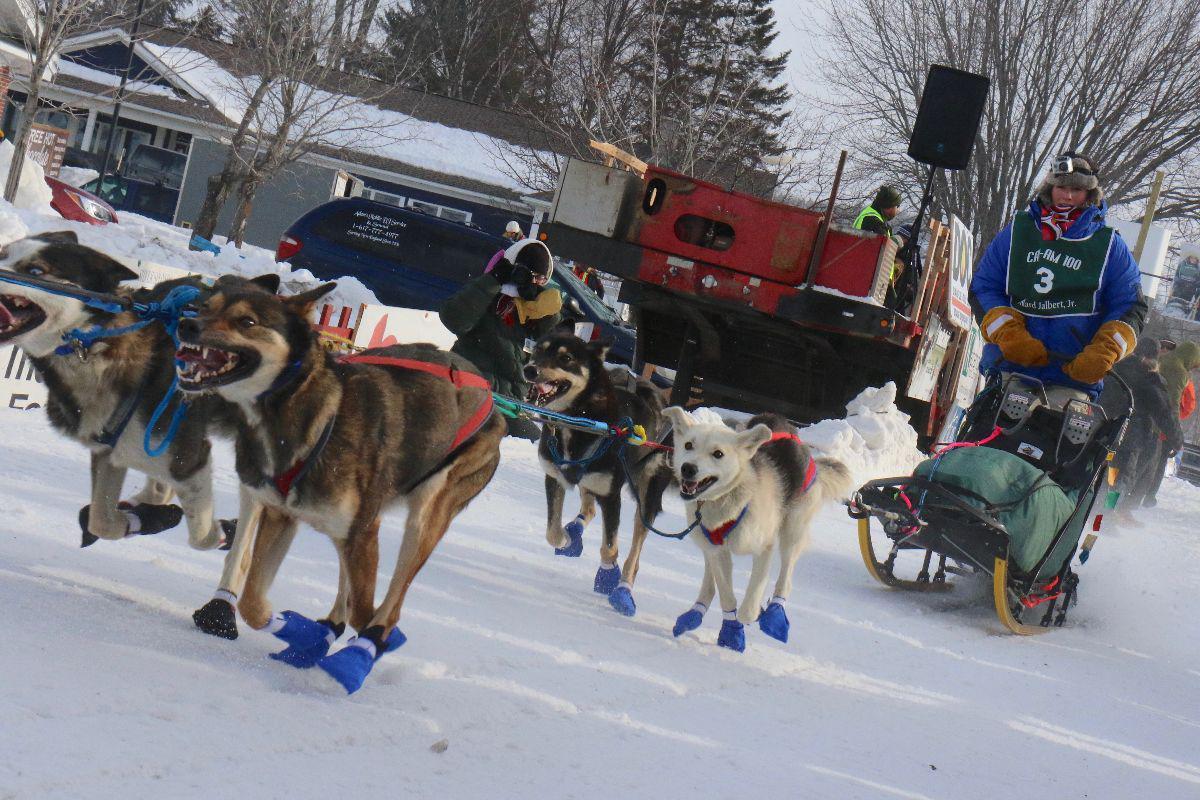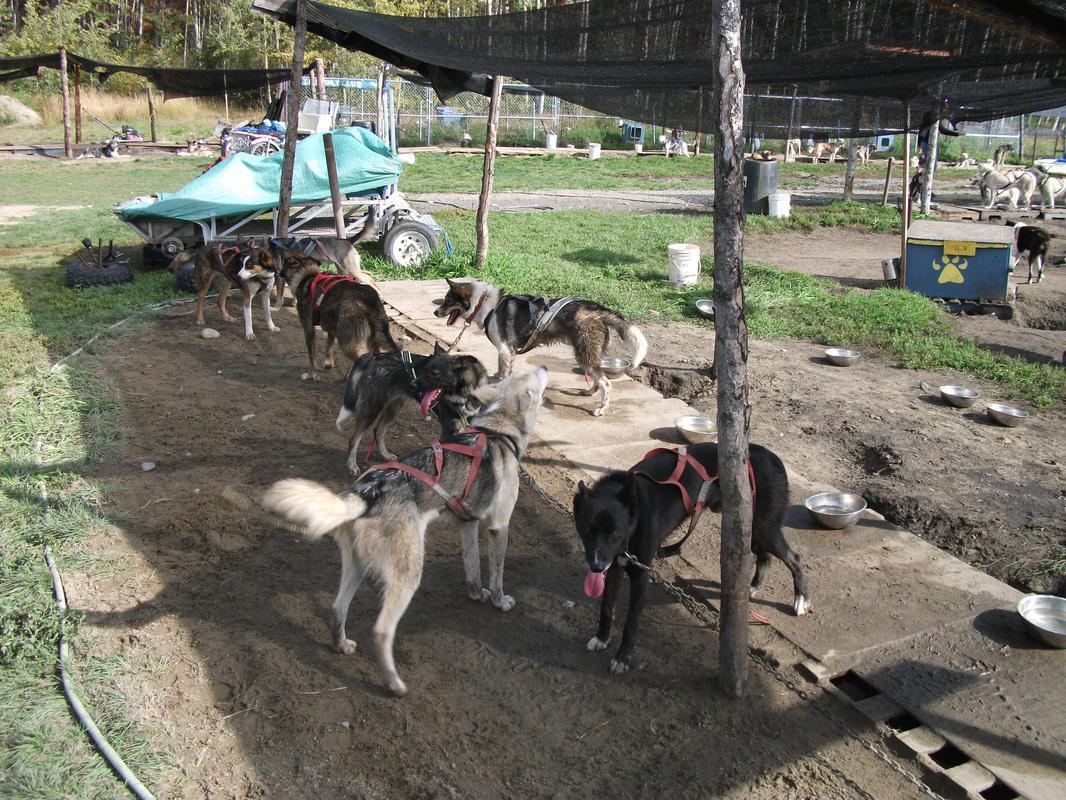The first image is the image on the left, the second image is the image on the right. Evaluate the accuracy of this statement regarding the images: "One dog team is crossing snowy ground while the other is hitched to a wheeled cart on a dry road.". Is it true? Answer yes or no. No. The first image is the image on the left, the second image is the image on the right. Analyze the images presented: Is the assertion "The image on the left shows a dog team running in snow." valid? Answer yes or no. Yes. 